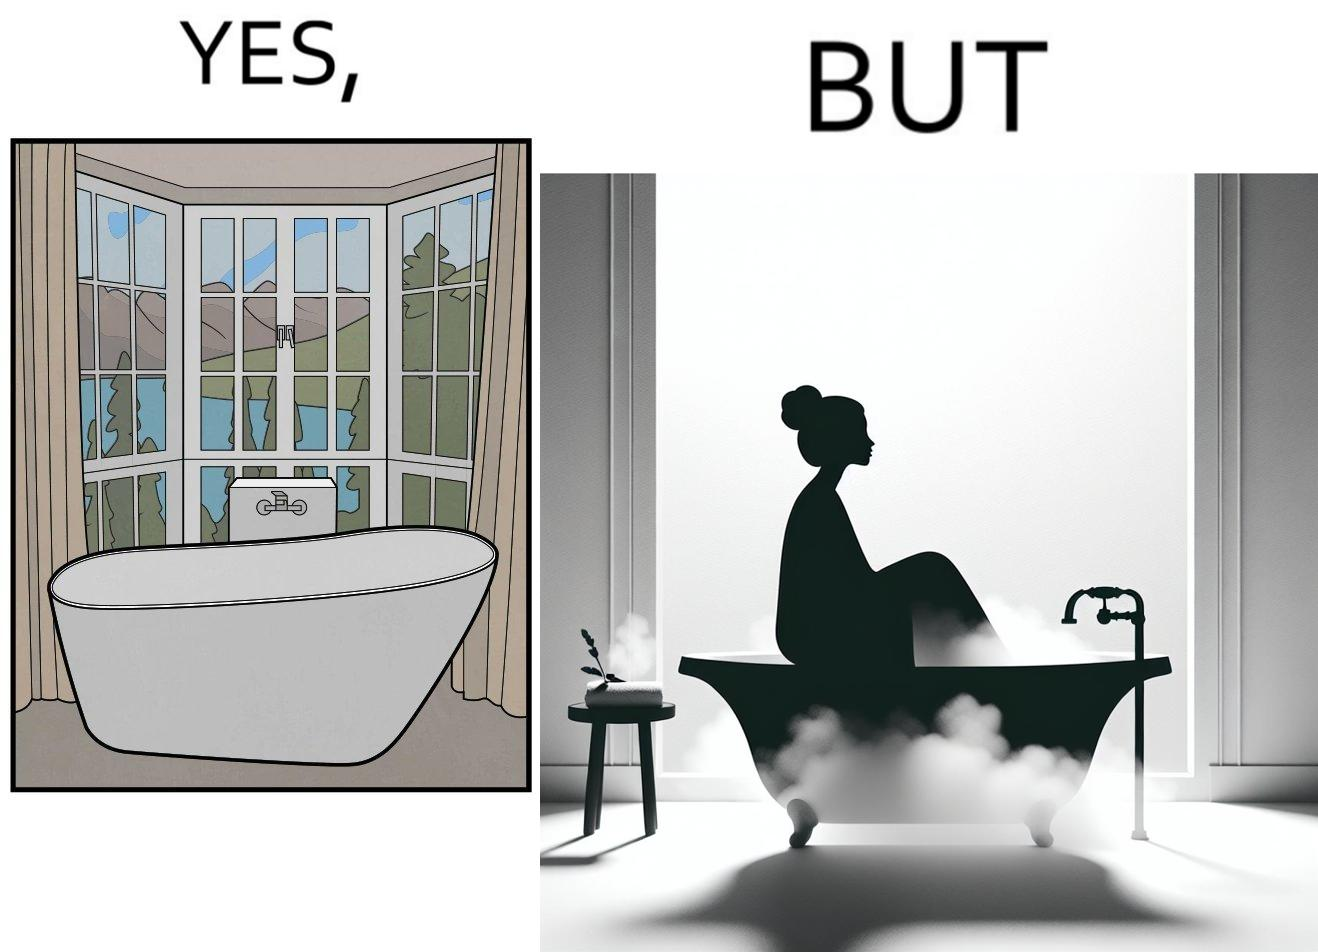Provide a description of this image. The image is ironical, as a bathtub near a window having a very scenic view, becomes misty when someone is bathing, thus making the scenic view blurry. 